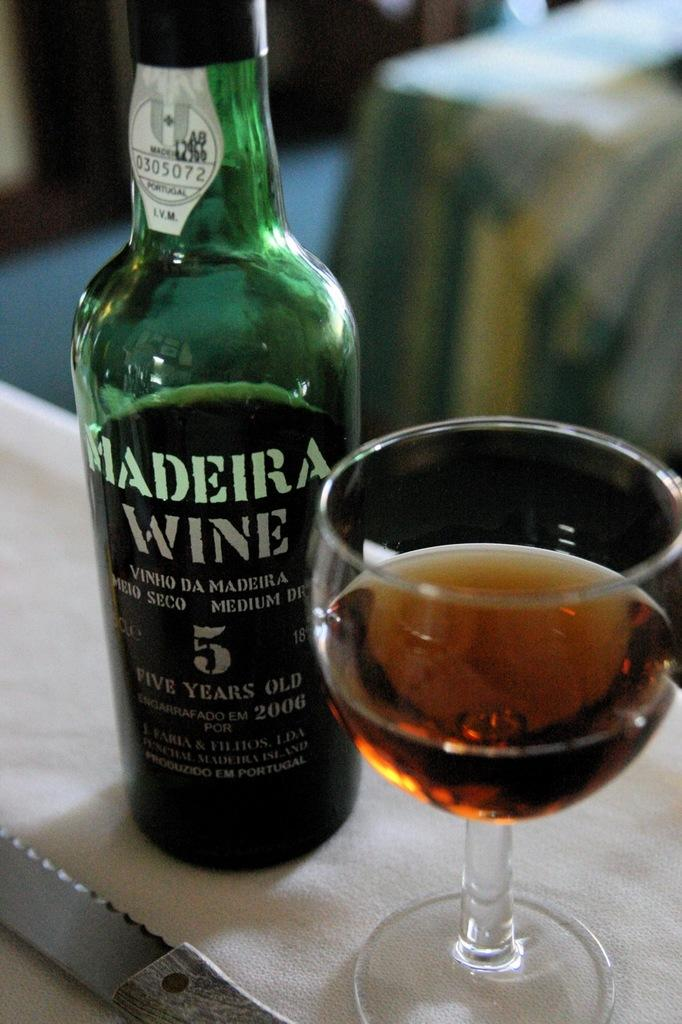<image>
Present a compact description of the photo's key features. A glass of 5 year old Madeira wine is to the right of the bottle. 